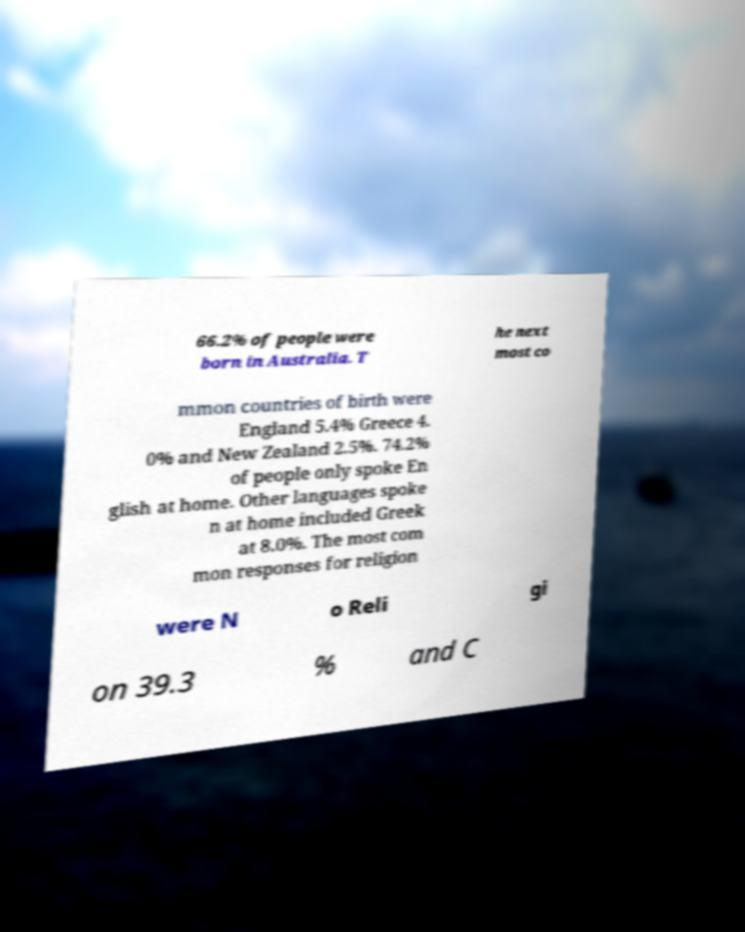Please read and relay the text visible in this image. What does it say? 66.2% of people were born in Australia. T he next most co mmon countries of birth were England 5.4% Greece 4. 0% and New Zealand 2.5%. 74.2% of people only spoke En glish at home. Other languages spoke n at home included Greek at 8.0%. The most com mon responses for religion were N o Reli gi on 39.3 % and C 